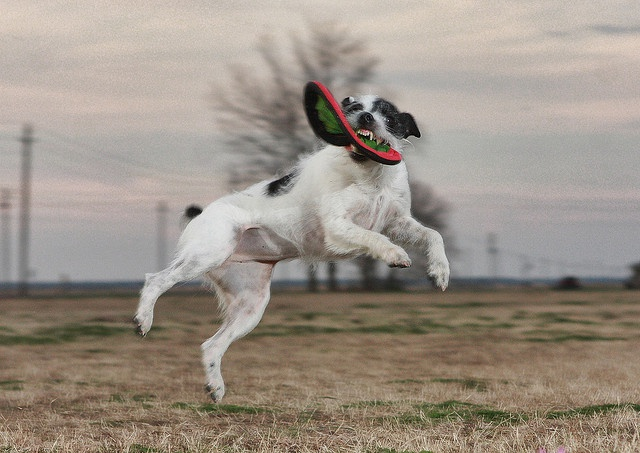Describe the objects in this image and their specific colors. I can see dog in lightgray, darkgray, gray, and black tones and frisbee in lightgray, black, darkgreen, gray, and brown tones in this image. 